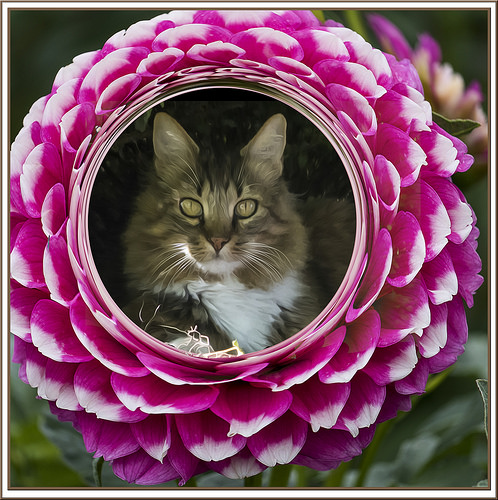<image>
Is the cat to the right of the flower? No. The cat is not to the right of the flower. The horizontal positioning shows a different relationship. Is there a cat behind the flower? No. The cat is not behind the flower. From this viewpoint, the cat appears to be positioned elsewhere in the scene. Is there a cat in the flower? Yes. The cat is contained within or inside the flower, showing a containment relationship. 